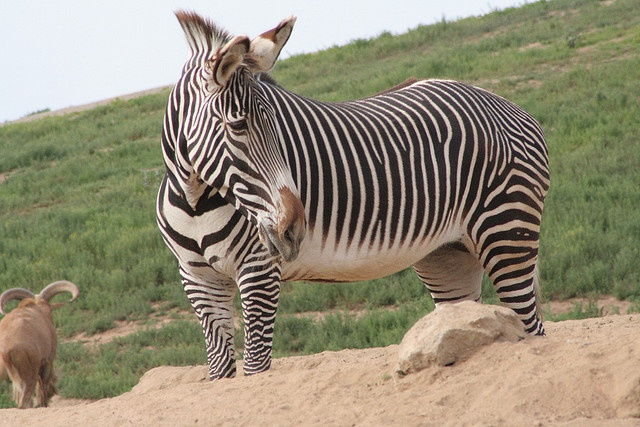Describe the objects in this image and their specific colors. I can see zebra in white, black, darkgray, and gray tones and sheep in white, gray, maroon, and tan tones in this image. 